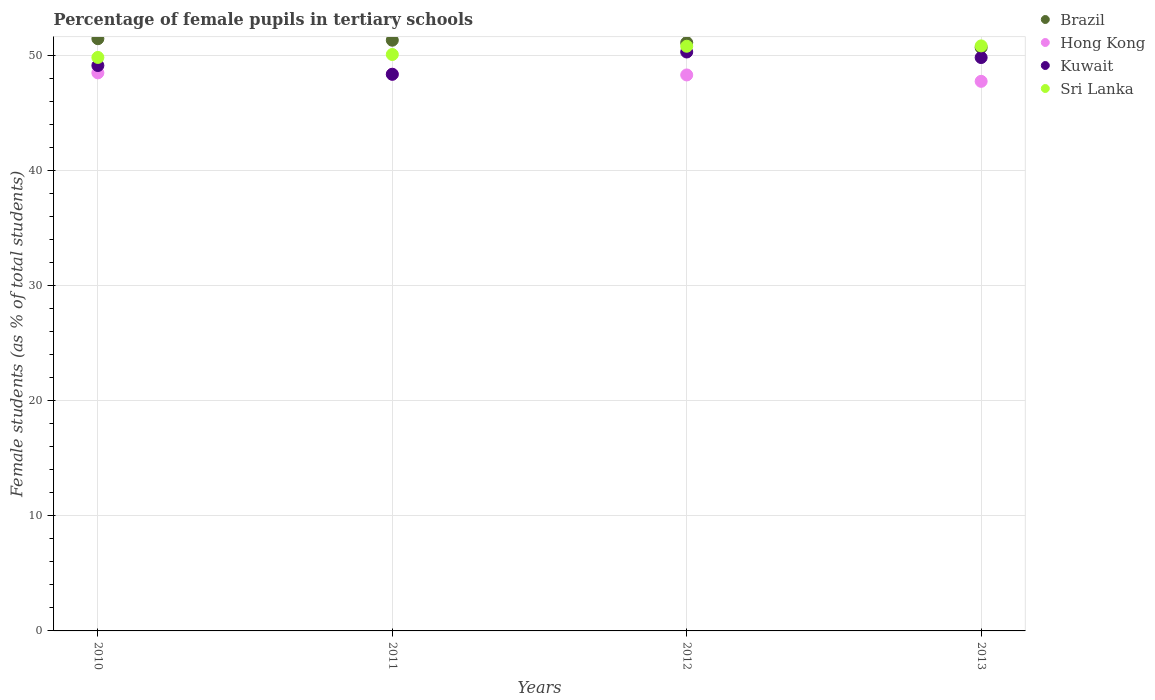Is the number of dotlines equal to the number of legend labels?
Provide a succinct answer. Yes. What is the percentage of female pupils in tertiary schools in Kuwait in 2011?
Your response must be concise. 48.4. Across all years, what is the maximum percentage of female pupils in tertiary schools in Sri Lanka?
Your answer should be very brief. 50.87. Across all years, what is the minimum percentage of female pupils in tertiary schools in Hong Kong?
Your answer should be very brief. 47.79. In which year was the percentage of female pupils in tertiary schools in Brazil maximum?
Your answer should be compact. 2010. In which year was the percentage of female pupils in tertiary schools in Hong Kong minimum?
Keep it short and to the point. 2013. What is the total percentage of female pupils in tertiary schools in Sri Lanka in the graph?
Provide a succinct answer. 201.71. What is the difference between the percentage of female pupils in tertiary schools in Brazil in 2010 and that in 2013?
Offer a very short reply. 0.77. What is the difference between the percentage of female pupils in tertiary schools in Hong Kong in 2013 and the percentage of female pupils in tertiary schools in Brazil in 2012?
Your answer should be compact. -3.36. What is the average percentage of female pupils in tertiary schools in Kuwait per year?
Provide a short and direct response. 49.44. In the year 2010, what is the difference between the percentage of female pupils in tertiary schools in Sri Lanka and percentage of female pupils in tertiary schools in Hong Kong?
Offer a terse response. 1.34. What is the ratio of the percentage of female pupils in tertiary schools in Sri Lanka in 2010 to that in 2013?
Provide a succinct answer. 0.98. Is the difference between the percentage of female pupils in tertiary schools in Sri Lanka in 2010 and 2012 greater than the difference between the percentage of female pupils in tertiary schools in Hong Kong in 2010 and 2012?
Your answer should be compact. No. What is the difference between the highest and the second highest percentage of female pupils in tertiary schools in Sri Lanka?
Your answer should be compact. 0.03. What is the difference between the highest and the lowest percentage of female pupils in tertiary schools in Hong Kong?
Your answer should be very brief. 0.74. Is the sum of the percentage of female pupils in tertiary schools in Brazil in 2012 and 2013 greater than the maximum percentage of female pupils in tertiary schools in Hong Kong across all years?
Keep it short and to the point. Yes. Is the percentage of female pupils in tertiary schools in Kuwait strictly greater than the percentage of female pupils in tertiary schools in Brazil over the years?
Your response must be concise. No. Is the percentage of female pupils in tertiary schools in Brazil strictly less than the percentage of female pupils in tertiary schools in Kuwait over the years?
Provide a short and direct response. No. How many dotlines are there?
Give a very brief answer. 4. What is the difference between two consecutive major ticks on the Y-axis?
Provide a short and direct response. 10. Does the graph contain any zero values?
Your answer should be compact. No. How many legend labels are there?
Make the answer very short. 4. What is the title of the graph?
Your answer should be compact. Percentage of female pupils in tertiary schools. Does "Turkmenistan" appear as one of the legend labels in the graph?
Make the answer very short. No. What is the label or title of the X-axis?
Your response must be concise. Years. What is the label or title of the Y-axis?
Your response must be concise. Female students (as % of total students). What is the Female students (as % of total students) in Brazil in 2010?
Make the answer very short. 51.5. What is the Female students (as % of total students) in Hong Kong in 2010?
Make the answer very short. 48.53. What is the Female students (as % of total students) of Kuwait in 2010?
Keep it short and to the point. 49.17. What is the Female students (as % of total students) of Sri Lanka in 2010?
Provide a short and direct response. 49.87. What is the Female students (as % of total students) in Brazil in 2011?
Provide a short and direct response. 51.37. What is the Female students (as % of total students) of Hong Kong in 2011?
Provide a short and direct response. 48.42. What is the Female students (as % of total students) in Kuwait in 2011?
Your answer should be very brief. 48.4. What is the Female students (as % of total students) of Sri Lanka in 2011?
Your answer should be compact. 50.13. What is the Female students (as % of total students) of Brazil in 2012?
Ensure brevity in your answer.  51.15. What is the Female students (as % of total students) in Hong Kong in 2012?
Give a very brief answer. 48.35. What is the Female students (as % of total students) in Kuwait in 2012?
Make the answer very short. 50.34. What is the Female students (as % of total students) of Sri Lanka in 2012?
Give a very brief answer. 50.84. What is the Female students (as % of total students) of Brazil in 2013?
Provide a succinct answer. 50.73. What is the Female students (as % of total students) of Hong Kong in 2013?
Your answer should be compact. 47.79. What is the Female students (as % of total students) of Kuwait in 2013?
Provide a succinct answer. 49.86. What is the Female students (as % of total students) of Sri Lanka in 2013?
Give a very brief answer. 50.87. Across all years, what is the maximum Female students (as % of total students) in Brazil?
Keep it short and to the point. 51.5. Across all years, what is the maximum Female students (as % of total students) in Hong Kong?
Keep it short and to the point. 48.53. Across all years, what is the maximum Female students (as % of total students) of Kuwait?
Make the answer very short. 50.34. Across all years, what is the maximum Female students (as % of total students) in Sri Lanka?
Provide a short and direct response. 50.87. Across all years, what is the minimum Female students (as % of total students) in Brazil?
Ensure brevity in your answer.  50.73. Across all years, what is the minimum Female students (as % of total students) in Hong Kong?
Your answer should be very brief. 47.79. Across all years, what is the minimum Female students (as % of total students) in Kuwait?
Offer a very short reply. 48.4. Across all years, what is the minimum Female students (as % of total students) in Sri Lanka?
Your answer should be compact. 49.87. What is the total Female students (as % of total students) in Brazil in the graph?
Offer a terse response. 204.75. What is the total Female students (as % of total students) in Hong Kong in the graph?
Your answer should be compact. 193.08. What is the total Female students (as % of total students) in Kuwait in the graph?
Provide a succinct answer. 197.77. What is the total Female students (as % of total students) of Sri Lanka in the graph?
Your response must be concise. 201.71. What is the difference between the Female students (as % of total students) in Brazil in 2010 and that in 2011?
Give a very brief answer. 0.13. What is the difference between the Female students (as % of total students) of Hong Kong in 2010 and that in 2011?
Provide a short and direct response. 0.11. What is the difference between the Female students (as % of total students) of Kuwait in 2010 and that in 2011?
Your answer should be compact. 0.76. What is the difference between the Female students (as % of total students) of Sri Lanka in 2010 and that in 2011?
Give a very brief answer. -0.26. What is the difference between the Female students (as % of total students) of Brazil in 2010 and that in 2012?
Your answer should be compact. 0.34. What is the difference between the Female students (as % of total students) of Hong Kong in 2010 and that in 2012?
Give a very brief answer. 0.18. What is the difference between the Female students (as % of total students) in Kuwait in 2010 and that in 2012?
Provide a succinct answer. -1.18. What is the difference between the Female students (as % of total students) of Sri Lanka in 2010 and that in 2012?
Provide a succinct answer. -0.97. What is the difference between the Female students (as % of total students) in Brazil in 2010 and that in 2013?
Your answer should be compact. 0.77. What is the difference between the Female students (as % of total students) in Hong Kong in 2010 and that in 2013?
Keep it short and to the point. 0.74. What is the difference between the Female students (as % of total students) in Kuwait in 2010 and that in 2013?
Your response must be concise. -0.69. What is the difference between the Female students (as % of total students) in Sri Lanka in 2010 and that in 2013?
Your answer should be very brief. -1. What is the difference between the Female students (as % of total students) in Brazil in 2011 and that in 2012?
Your answer should be compact. 0.21. What is the difference between the Female students (as % of total students) of Hong Kong in 2011 and that in 2012?
Provide a succinct answer. 0.07. What is the difference between the Female students (as % of total students) of Kuwait in 2011 and that in 2012?
Your response must be concise. -1.94. What is the difference between the Female students (as % of total students) in Sri Lanka in 2011 and that in 2012?
Keep it short and to the point. -0.72. What is the difference between the Female students (as % of total students) in Brazil in 2011 and that in 2013?
Offer a terse response. 0.64. What is the difference between the Female students (as % of total students) of Hong Kong in 2011 and that in 2013?
Your answer should be very brief. 0.63. What is the difference between the Female students (as % of total students) in Kuwait in 2011 and that in 2013?
Your answer should be compact. -1.46. What is the difference between the Female students (as % of total students) in Sri Lanka in 2011 and that in 2013?
Give a very brief answer. -0.75. What is the difference between the Female students (as % of total students) of Brazil in 2012 and that in 2013?
Give a very brief answer. 0.42. What is the difference between the Female students (as % of total students) of Hong Kong in 2012 and that in 2013?
Give a very brief answer. 0.56. What is the difference between the Female students (as % of total students) in Kuwait in 2012 and that in 2013?
Your answer should be very brief. 0.48. What is the difference between the Female students (as % of total students) of Sri Lanka in 2012 and that in 2013?
Your answer should be compact. -0.03. What is the difference between the Female students (as % of total students) of Brazil in 2010 and the Female students (as % of total students) of Hong Kong in 2011?
Keep it short and to the point. 3.08. What is the difference between the Female students (as % of total students) of Brazil in 2010 and the Female students (as % of total students) of Kuwait in 2011?
Your answer should be very brief. 3.09. What is the difference between the Female students (as % of total students) of Brazil in 2010 and the Female students (as % of total students) of Sri Lanka in 2011?
Offer a very short reply. 1.37. What is the difference between the Female students (as % of total students) in Hong Kong in 2010 and the Female students (as % of total students) in Kuwait in 2011?
Give a very brief answer. 0.12. What is the difference between the Female students (as % of total students) of Hong Kong in 2010 and the Female students (as % of total students) of Sri Lanka in 2011?
Give a very brief answer. -1.6. What is the difference between the Female students (as % of total students) in Kuwait in 2010 and the Female students (as % of total students) in Sri Lanka in 2011?
Give a very brief answer. -0.96. What is the difference between the Female students (as % of total students) in Brazil in 2010 and the Female students (as % of total students) in Hong Kong in 2012?
Keep it short and to the point. 3.15. What is the difference between the Female students (as % of total students) in Brazil in 2010 and the Female students (as % of total students) in Kuwait in 2012?
Provide a succinct answer. 1.16. What is the difference between the Female students (as % of total students) of Brazil in 2010 and the Female students (as % of total students) of Sri Lanka in 2012?
Offer a very short reply. 0.66. What is the difference between the Female students (as % of total students) of Hong Kong in 2010 and the Female students (as % of total students) of Kuwait in 2012?
Provide a short and direct response. -1.82. What is the difference between the Female students (as % of total students) in Hong Kong in 2010 and the Female students (as % of total students) in Sri Lanka in 2012?
Your response must be concise. -2.32. What is the difference between the Female students (as % of total students) in Kuwait in 2010 and the Female students (as % of total students) in Sri Lanka in 2012?
Give a very brief answer. -1.68. What is the difference between the Female students (as % of total students) in Brazil in 2010 and the Female students (as % of total students) in Hong Kong in 2013?
Provide a succinct answer. 3.71. What is the difference between the Female students (as % of total students) of Brazil in 2010 and the Female students (as % of total students) of Kuwait in 2013?
Keep it short and to the point. 1.64. What is the difference between the Female students (as % of total students) in Brazil in 2010 and the Female students (as % of total students) in Sri Lanka in 2013?
Your answer should be very brief. 0.63. What is the difference between the Female students (as % of total students) of Hong Kong in 2010 and the Female students (as % of total students) of Kuwait in 2013?
Your answer should be compact. -1.33. What is the difference between the Female students (as % of total students) in Hong Kong in 2010 and the Female students (as % of total students) in Sri Lanka in 2013?
Keep it short and to the point. -2.35. What is the difference between the Female students (as % of total students) of Kuwait in 2010 and the Female students (as % of total students) of Sri Lanka in 2013?
Provide a short and direct response. -1.71. What is the difference between the Female students (as % of total students) in Brazil in 2011 and the Female students (as % of total students) in Hong Kong in 2012?
Ensure brevity in your answer.  3.02. What is the difference between the Female students (as % of total students) in Brazil in 2011 and the Female students (as % of total students) in Kuwait in 2012?
Your answer should be compact. 1.03. What is the difference between the Female students (as % of total students) of Brazil in 2011 and the Female students (as % of total students) of Sri Lanka in 2012?
Make the answer very short. 0.52. What is the difference between the Female students (as % of total students) in Hong Kong in 2011 and the Female students (as % of total students) in Kuwait in 2012?
Offer a very short reply. -1.92. What is the difference between the Female students (as % of total students) in Hong Kong in 2011 and the Female students (as % of total students) in Sri Lanka in 2012?
Ensure brevity in your answer.  -2.43. What is the difference between the Female students (as % of total students) in Kuwait in 2011 and the Female students (as % of total students) in Sri Lanka in 2012?
Provide a short and direct response. -2.44. What is the difference between the Female students (as % of total students) in Brazil in 2011 and the Female students (as % of total students) in Hong Kong in 2013?
Provide a short and direct response. 3.58. What is the difference between the Female students (as % of total students) of Brazil in 2011 and the Female students (as % of total students) of Kuwait in 2013?
Give a very brief answer. 1.51. What is the difference between the Female students (as % of total students) in Brazil in 2011 and the Female students (as % of total students) in Sri Lanka in 2013?
Provide a succinct answer. 0.49. What is the difference between the Female students (as % of total students) in Hong Kong in 2011 and the Female students (as % of total students) in Kuwait in 2013?
Keep it short and to the point. -1.44. What is the difference between the Female students (as % of total students) of Hong Kong in 2011 and the Female students (as % of total students) of Sri Lanka in 2013?
Your response must be concise. -2.46. What is the difference between the Female students (as % of total students) of Kuwait in 2011 and the Female students (as % of total students) of Sri Lanka in 2013?
Offer a very short reply. -2.47. What is the difference between the Female students (as % of total students) in Brazil in 2012 and the Female students (as % of total students) in Hong Kong in 2013?
Your answer should be compact. 3.36. What is the difference between the Female students (as % of total students) of Brazil in 2012 and the Female students (as % of total students) of Kuwait in 2013?
Offer a terse response. 1.29. What is the difference between the Female students (as % of total students) of Brazil in 2012 and the Female students (as % of total students) of Sri Lanka in 2013?
Provide a short and direct response. 0.28. What is the difference between the Female students (as % of total students) of Hong Kong in 2012 and the Female students (as % of total students) of Kuwait in 2013?
Provide a succinct answer. -1.51. What is the difference between the Female students (as % of total students) in Hong Kong in 2012 and the Female students (as % of total students) in Sri Lanka in 2013?
Ensure brevity in your answer.  -2.53. What is the difference between the Female students (as % of total students) of Kuwait in 2012 and the Female students (as % of total students) of Sri Lanka in 2013?
Offer a very short reply. -0.53. What is the average Female students (as % of total students) of Brazil per year?
Give a very brief answer. 51.19. What is the average Female students (as % of total students) in Hong Kong per year?
Make the answer very short. 48.27. What is the average Female students (as % of total students) in Kuwait per year?
Your answer should be compact. 49.44. What is the average Female students (as % of total students) in Sri Lanka per year?
Ensure brevity in your answer.  50.43. In the year 2010, what is the difference between the Female students (as % of total students) of Brazil and Female students (as % of total students) of Hong Kong?
Keep it short and to the point. 2.97. In the year 2010, what is the difference between the Female students (as % of total students) in Brazil and Female students (as % of total students) in Kuwait?
Offer a terse response. 2.33. In the year 2010, what is the difference between the Female students (as % of total students) of Brazil and Female students (as % of total students) of Sri Lanka?
Keep it short and to the point. 1.63. In the year 2010, what is the difference between the Female students (as % of total students) in Hong Kong and Female students (as % of total students) in Kuwait?
Make the answer very short. -0.64. In the year 2010, what is the difference between the Female students (as % of total students) in Hong Kong and Female students (as % of total students) in Sri Lanka?
Ensure brevity in your answer.  -1.34. In the year 2010, what is the difference between the Female students (as % of total students) of Kuwait and Female students (as % of total students) of Sri Lanka?
Offer a very short reply. -0.7. In the year 2011, what is the difference between the Female students (as % of total students) in Brazil and Female students (as % of total students) in Hong Kong?
Offer a very short reply. 2.95. In the year 2011, what is the difference between the Female students (as % of total students) of Brazil and Female students (as % of total students) of Kuwait?
Make the answer very short. 2.96. In the year 2011, what is the difference between the Female students (as % of total students) in Brazil and Female students (as % of total students) in Sri Lanka?
Ensure brevity in your answer.  1.24. In the year 2011, what is the difference between the Female students (as % of total students) of Hong Kong and Female students (as % of total students) of Kuwait?
Make the answer very short. 0.01. In the year 2011, what is the difference between the Female students (as % of total students) in Hong Kong and Female students (as % of total students) in Sri Lanka?
Your answer should be compact. -1.71. In the year 2011, what is the difference between the Female students (as % of total students) in Kuwait and Female students (as % of total students) in Sri Lanka?
Your response must be concise. -1.72. In the year 2012, what is the difference between the Female students (as % of total students) of Brazil and Female students (as % of total students) of Hong Kong?
Offer a terse response. 2.81. In the year 2012, what is the difference between the Female students (as % of total students) of Brazil and Female students (as % of total students) of Kuwait?
Keep it short and to the point. 0.81. In the year 2012, what is the difference between the Female students (as % of total students) in Brazil and Female students (as % of total students) in Sri Lanka?
Provide a succinct answer. 0.31. In the year 2012, what is the difference between the Female students (as % of total students) of Hong Kong and Female students (as % of total students) of Kuwait?
Provide a succinct answer. -2. In the year 2012, what is the difference between the Female students (as % of total students) of Hong Kong and Female students (as % of total students) of Sri Lanka?
Keep it short and to the point. -2.5. In the year 2012, what is the difference between the Female students (as % of total students) of Kuwait and Female students (as % of total students) of Sri Lanka?
Provide a short and direct response. -0.5. In the year 2013, what is the difference between the Female students (as % of total students) of Brazil and Female students (as % of total students) of Hong Kong?
Provide a short and direct response. 2.94. In the year 2013, what is the difference between the Female students (as % of total students) of Brazil and Female students (as % of total students) of Kuwait?
Keep it short and to the point. 0.87. In the year 2013, what is the difference between the Female students (as % of total students) in Brazil and Female students (as % of total students) in Sri Lanka?
Provide a succinct answer. -0.14. In the year 2013, what is the difference between the Female students (as % of total students) of Hong Kong and Female students (as % of total students) of Kuwait?
Offer a terse response. -2.07. In the year 2013, what is the difference between the Female students (as % of total students) in Hong Kong and Female students (as % of total students) in Sri Lanka?
Keep it short and to the point. -3.08. In the year 2013, what is the difference between the Female students (as % of total students) in Kuwait and Female students (as % of total students) in Sri Lanka?
Your answer should be compact. -1.01. What is the ratio of the Female students (as % of total students) in Brazil in 2010 to that in 2011?
Make the answer very short. 1. What is the ratio of the Female students (as % of total students) of Hong Kong in 2010 to that in 2011?
Offer a very short reply. 1. What is the ratio of the Female students (as % of total students) of Kuwait in 2010 to that in 2011?
Make the answer very short. 1.02. What is the ratio of the Female students (as % of total students) in Brazil in 2010 to that in 2012?
Your answer should be compact. 1.01. What is the ratio of the Female students (as % of total students) in Hong Kong in 2010 to that in 2012?
Your answer should be very brief. 1. What is the ratio of the Female students (as % of total students) of Kuwait in 2010 to that in 2012?
Provide a short and direct response. 0.98. What is the ratio of the Female students (as % of total students) of Sri Lanka in 2010 to that in 2012?
Provide a succinct answer. 0.98. What is the ratio of the Female students (as % of total students) of Brazil in 2010 to that in 2013?
Offer a terse response. 1.02. What is the ratio of the Female students (as % of total students) in Hong Kong in 2010 to that in 2013?
Give a very brief answer. 1.02. What is the ratio of the Female students (as % of total students) of Kuwait in 2010 to that in 2013?
Keep it short and to the point. 0.99. What is the ratio of the Female students (as % of total students) of Sri Lanka in 2010 to that in 2013?
Provide a succinct answer. 0.98. What is the ratio of the Female students (as % of total students) of Brazil in 2011 to that in 2012?
Offer a terse response. 1. What is the ratio of the Female students (as % of total students) of Hong Kong in 2011 to that in 2012?
Your response must be concise. 1. What is the ratio of the Female students (as % of total students) in Kuwait in 2011 to that in 2012?
Provide a short and direct response. 0.96. What is the ratio of the Female students (as % of total students) in Sri Lanka in 2011 to that in 2012?
Keep it short and to the point. 0.99. What is the ratio of the Female students (as % of total students) of Brazil in 2011 to that in 2013?
Your answer should be very brief. 1.01. What is the ratio of the Female students (as % of total students) in Hong Kong in 2011 to that in 2013?
Provide a short and direct response. 1.01. What is the ratio of the Female students (as % of total students) of Kuwait in 2011 to that in 2013?
Offer a terse response. 0.97. What is the ratio of the Female students (as % of total students) of Brazil in 2012 to that in 2013?
Your response must be concise. 1.01. What is the ratio of the Female students (as % of total students) in Hong Kong in 2012 to that in 2013?
Your answer should be compact. 1.01. What is the ratio of the Female students (as % of total students) of Kuwait in 2012 to that in 2013?
Ensure brevity in your answer.  1.01. What is the ratio of the Female students (as % of total students) of Sri Lanka in 2012 to that in 2013?
Keep it short and to the point. 1. What is the difference between the highest and the second highest Female students (as % of total students) of Brazil?
Your answer should be very brief. 0.13. What is the difference between the highest and the second highest Female students (as % of total students) in Hong Kong?
Your response must be concise. 0.11. What is the difference between the highest and the second highest Female students (as % of total students) of Kuwait?
Your response must be concise. 0.48. What is the difference between the highest and the second highest Female students (as % of total students) in Sri Lanka?
Provide a succinct answer. 0.03. What is the difference between the highest and the lowest Female students (as % of total students) in Brazil?
Make the answer very short. 0.77. What is the difference between the highest and the lowest Female students (as % of total students) in Hong Kong?
Make the answer very short. 0.74. What is the difference between the highest and the lowest Female students (as % of total students) of Kuwait?
Your answer should be very brief. 1.94. What is the difference between the highest and the lowest Female students (as % of total students) in Sri Lanka?
Your answer should be very brief. 1. 